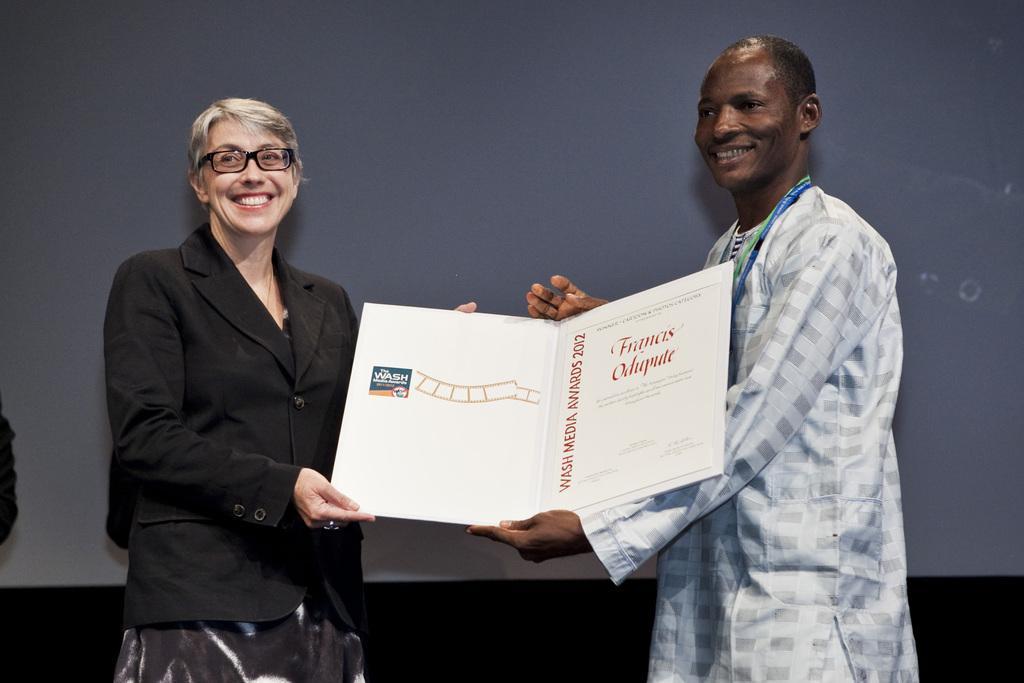Can you describe this image briefly? In this image we can see there are two persons standing and holding a card with a smile. In the background there is a wall. 